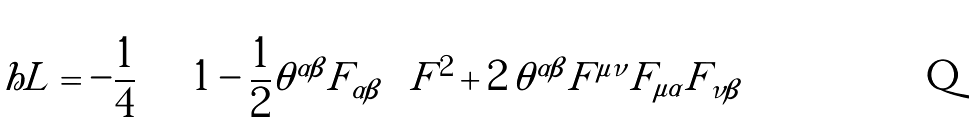Convert formula to latex. <formula><loc_0><loc_0><loc_500><loc_500>\ h L = - \frac { 1 } { 4 } \, \left [ \left ( 1 - \frac { 1 } { 2 } \theta ^ { \alpha \beta } F _ { \alpha \beta } \right ) F ^ { 2 } + 2 \, \theta ^ { \alpha \beta } F ^ { \mu \nu } F _ { \mu \alpha } F _ { \nu \beta } \right ]</formula> 